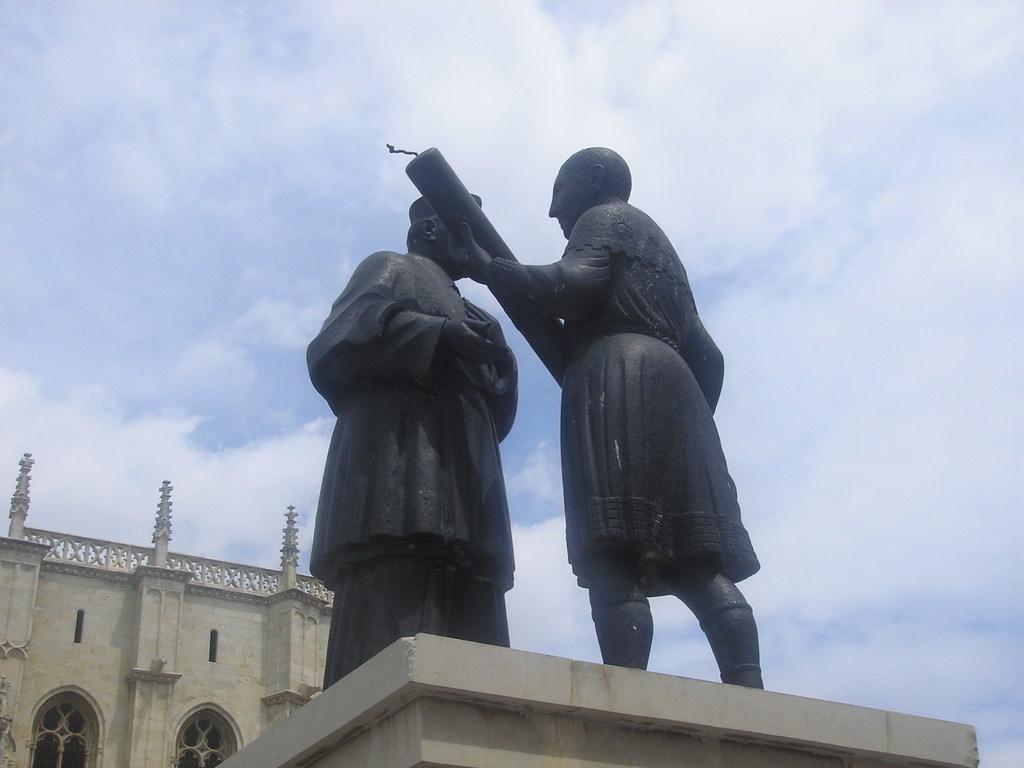Could you give a brief overview of what you see in this image? In front of the picture, we see two statues. In the background, we see a building in white color. At the top of the picture, we see the sky. 